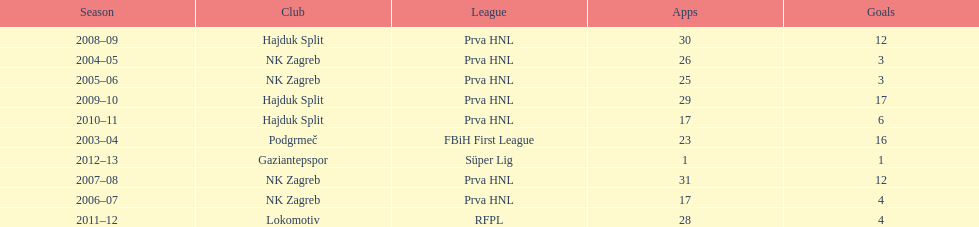What is the highest number of goals scored by senijad ibri&#269;i&#263; in a season? 35. 